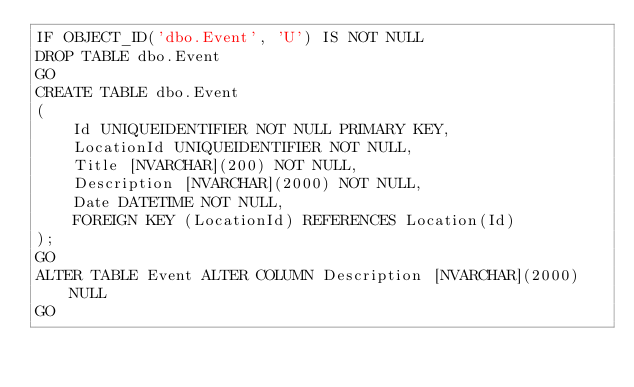Convert code to text. <code><loc_0><loc_0><loc_500><loc_500><_SQL_>IF OBJECT_ID('dbo.Event', 'U') IS NOT NULL
DROP TABLE dbo.Event
GO
CREATE TABLE dbo.Event
(
    Id UNIQUEIDENTIFIER NOT NULL PRIMARY KEY,
    LocationId UNIQUEIDENTIFIER NOT NULL,
    Title [NVARCHAR](200) NOT NULL,
    Description [NVARCHAR](2000) NOT NULL,
    Date DATETIME NOT NULL,
    FOREIGN KEY (LocationId) REFERENCES Location(Id)
);
GO
ALTER TABLE Event ALTER COLUMN Description [NVARCHAR](2000) NULL
GO</code> 